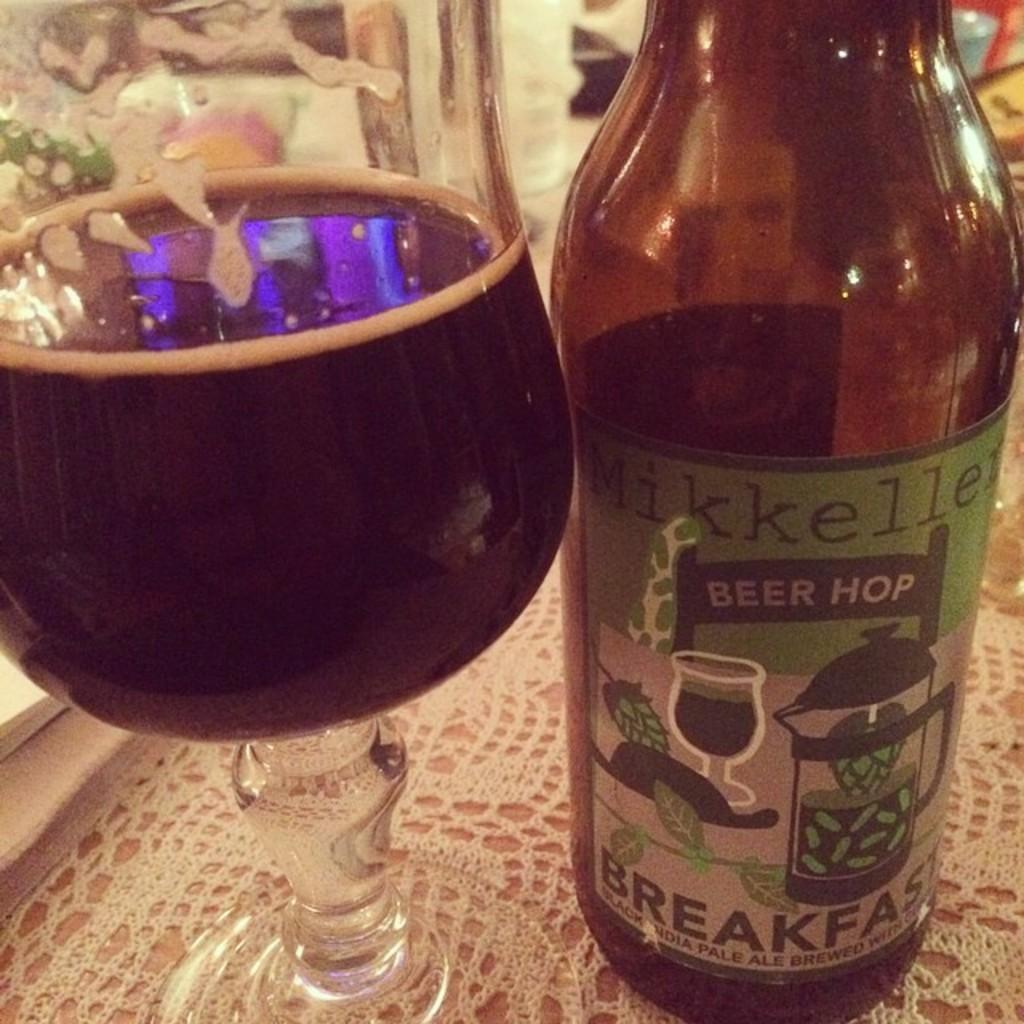<image>
Write a terse but informative summary of the picture. A bottle of beer that says breakfast on the label sits next to a glass. 